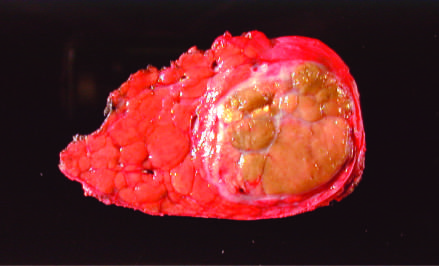does the wall of the aneurysm removed at autopsy show a unifocal, massive neoplasm replacing most of the right hepatic lobe in a noncirrhotic liver?
Answer the question using a single word or phrase. No 